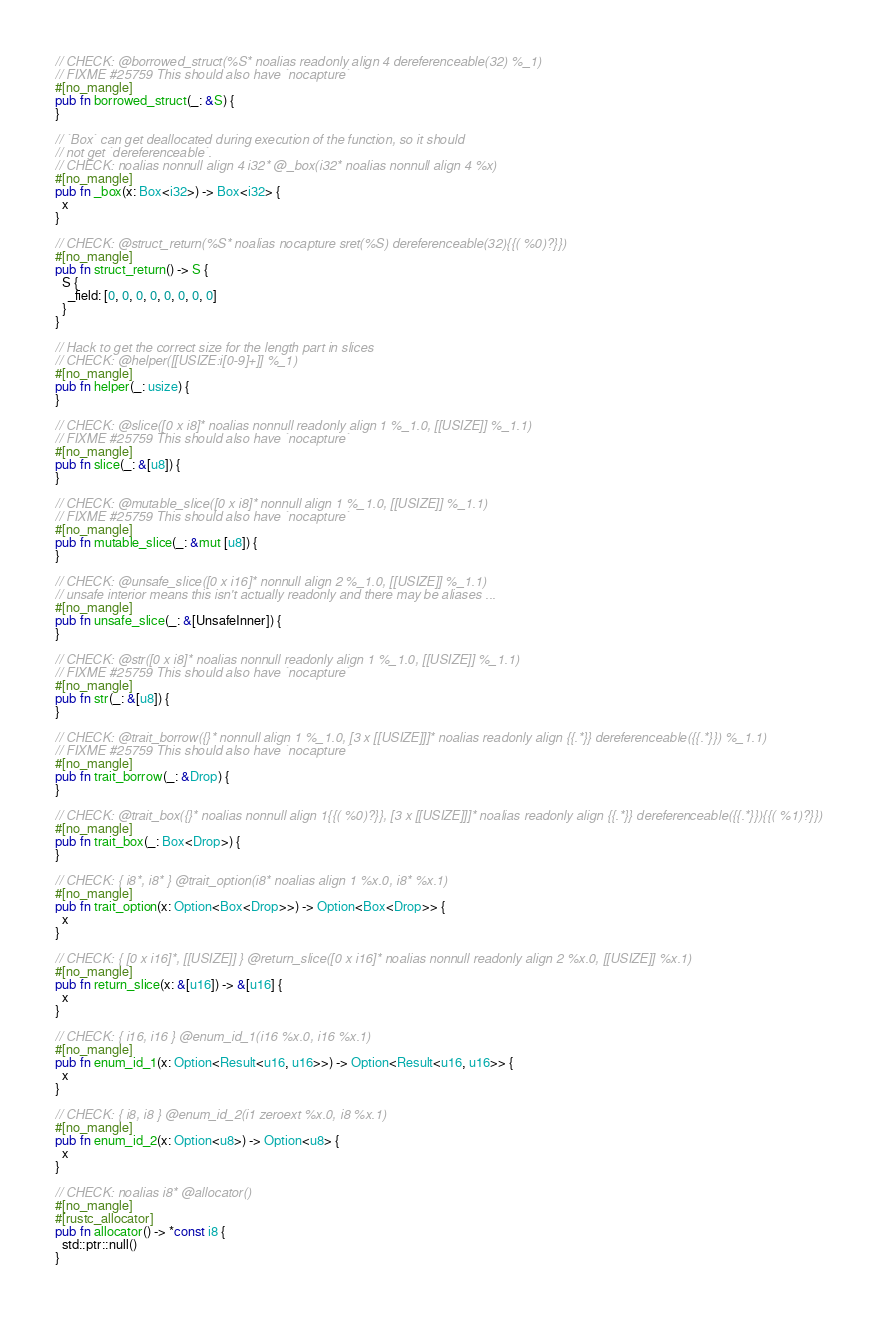<code> <loc_0><loc_0><loc_500><loc_500><_Rust_>
// CHECK: @borrowed_struct(%S* noalias readonly align 4 dereferenceable(32) %_1)
// FIXME #25759 This should also have `nocapture`
#[no_mangle]
pub fn borrowed_struct(_: &S) {
}

// `Box` can get deallocated during execution of the function, so it should
// not get `dereferenceable`.
// CHECK: noalias nonnull align 4 i32* @_box(i32* noalias nonnull align 4 %x)
#[no_mangle]
pub fn _box(x: Box<i32>) -> Box<i32> {
  x
}

// CHECK: @struct_return(%S* noalias nocapture sret(%S) dereferenceable(32){{( %0)?}})
#[no_mangle]
pub fn struct_return() -> S {
  S {
    _field: [0, 0, 0, 0, 0, 0, 0, 0]
  }
}

// Hack to get the correct size for the length part in slices
// CHECK: @helper([[USIZE:i[0-9]+]] %_1)
#[no_mangle]
pub fn helper(_: usize) {
}

// CHECK: @slice([0 x i8]* noalias nonnull readonly align 1 %_1.0, [[USIZE]] %_1.1)
// FIXME #25759 This should also have `nocapture`
#[no_mangle]
pub fn slice(_: &[u8]) {
}

// CHECK: @mutable_slice([0 x i8]* nonnull align 1 %_1.0, [[USIZE]] %_1.1)
// FIXME #25759 This should also have `nocapture`
#[no_mangle]
pub fn mutable_slice(_: &mut [u8]) {
}

// CHECK: @unsafe_slice([0 x i16]* nonnull align 2 %_1.0, [[USIZE]] %_1.1)
// unsafe interior means this isn't actually readonly and there may be aliases ...
#[no_mangle]
pub fn unsafe_slice(_: &[UnsafeInner]) {
}

// CHECK: @str([0 x i8]* noalias nonnull readonly align 1 %_1.0, [[USIZE]] %_1.1)
// FIXME #25759 This should also have `nocapture`
#[no_mangle]
pub fn str(_: &[u8]) {
}

// CHECK: @trait_borrow({}* nonnull align 1 %_1.0, [3 x [[USIZE]]]* noalias readonly align {{.*}} dereferenceable({{.*}}) %_1.1)
// FIXME #25759 This should also have `nocapture`
#[no_mangle]
pub fn trait_borrow(_: &Drop) {
}

// CHECK: @trait_box({}* noalias nonnull align 1{{( %0)?}}, [3 x [[USIZE]]]* noalias readonly align {{.*}} dereferenceable({{.*}}){{( %1)?}})
#[no_mangle]
pub fn trait_box(_: Box<Drop>) {
}

// CHECK: { i8*, i8* } @trait_option(i8* noalias align 1 %x.0, i8* %x.1)
#[no_mangle]
pub fn trait_option(x: Option<Box<Drop>>) -> Option<Box<Drop>> {
  x
}

// CHECK: { [0 x i16]*, [[USIZE]] } @return_slice([0 x i16]* noalias nonnull readonly align 2 %x.0, [[USIZE]] %x.1)
#[no_mangle]
pub fn return_slice(x: &[u16]) -> &[u16] {
  x
}

// CHECK: { i16, i16 } @enum_id_1(i16 %x.0, i16 %x.1)
#[no_mangle]
pub fn enum_id_1(x: Option<Result<u16, u16>>) -> Option<Result<u16, u16>> {
  x
}

// CHECK: { i8, i8 } @enum_id_2(i1 zeroext %x.0, i8 %x.1)
#[no_mangle]
pub fn enum_id_2(x: Option<u8>) -> Option<u8> {
  x
}

// CHECK: noalias i8* @allocator()
#[no_mangle]
#[rustc_allocator]
pub fn allocator() -> *const i8 {
  std::ptr::null()
}
</code> 